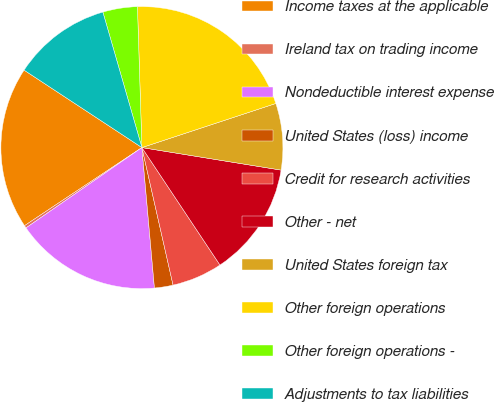Convert chart to OTSL. <chart><loc_0><loc_0><loc_500><loc_500><pie_chart><fcel>Income taxes at the applicable<fcel>Ireland tax on trading income<fcel>Nondeductible interest expense<fcel>United States (loss) income<fcel>Credit for research activities<fcel>Other - net<fcel>United States foreign tax<fcel>Other foreign operations<fcel>Other foreign operations -<fcel>Adjustments to tax liabilities<nl><fcel>18.6%<fcel>0.3%<fcel>16.77%<fcel>2.13%<fcel>5.79%<fcel>13.11%<fcel>7.62%<fcel>20.44%<fcel>3.96%<fcel>11.28%<nl></chart> 